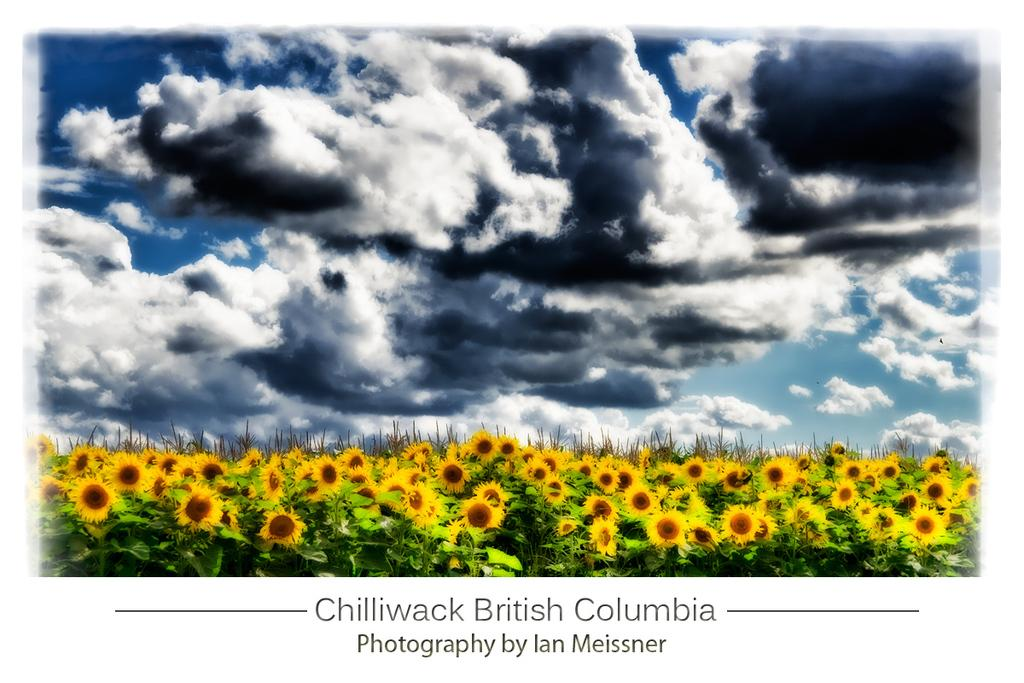What can be found in the foreground of the poster? There is text in the foreground of the poster. What type of flowers are depicted in the poster? Sunflowers are depicted in the poster. What other elements are included in the poster besides the text and flowers? The poster includes plants. What is visible in the top part of the poster? The sky is visible in the top part of the poster. What can be observed in the sky? Clouds are present in the sky. What type of machine is being used to write the text in the poster? There is no machine present in the poster; the text is likely printed or handwritten. Can you see an argument taking place between the sunflowers in the poster? There is no argument depicted in the poster; it features sunflowers and text. 